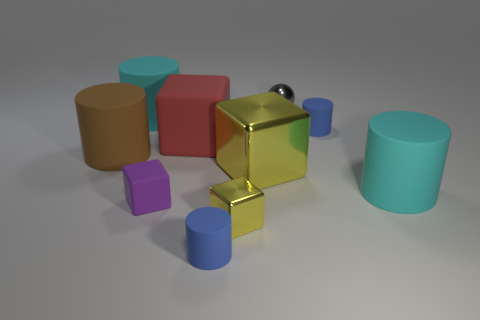Subtract all brown cylinders. How many cylinders are left? 4 Subtract all brown cylinders. How many cylinders are left? 4 Subtract all brown cylinders. Subtract all brown spheres. How many cylinders are left? 4 Subtract all spheres. How many objects are left? 9 Subtract 0 blue cubes. How many objects are left? 10 Subtract all small yellow metal blocks. Subtract all tiny gray cylinders. How many objects are left? 9 Add 4 gray balls. How many gray balls are left? 5 Add 2 purple cylinders. How many purple cylinders exist? 2 